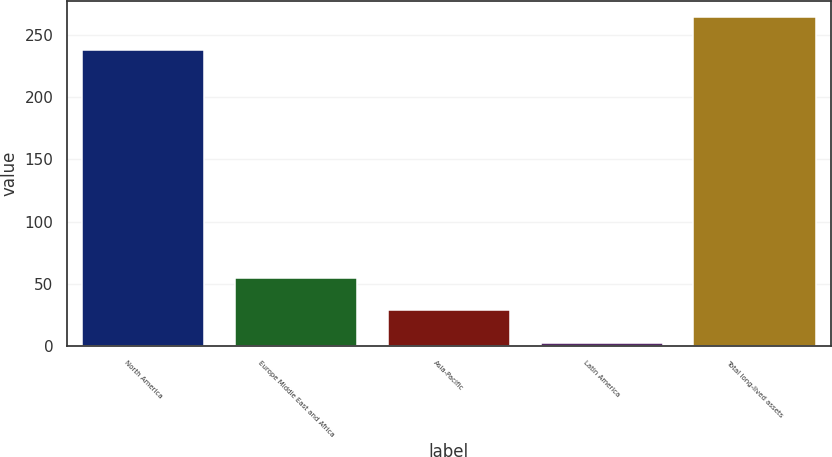<chart> <loc_0><loc_0><loc_500><loc_500><bar_chart><fcel>North America<fcel>Europe Middle East and Africa<fcel>Asia-Pacific<fcel>Latin America<fcel>Total long-lived assets<nl><fcel>238<fcel>55.2<fcel>29.1<fcel>3<fcel>264.1<nl></chart> 